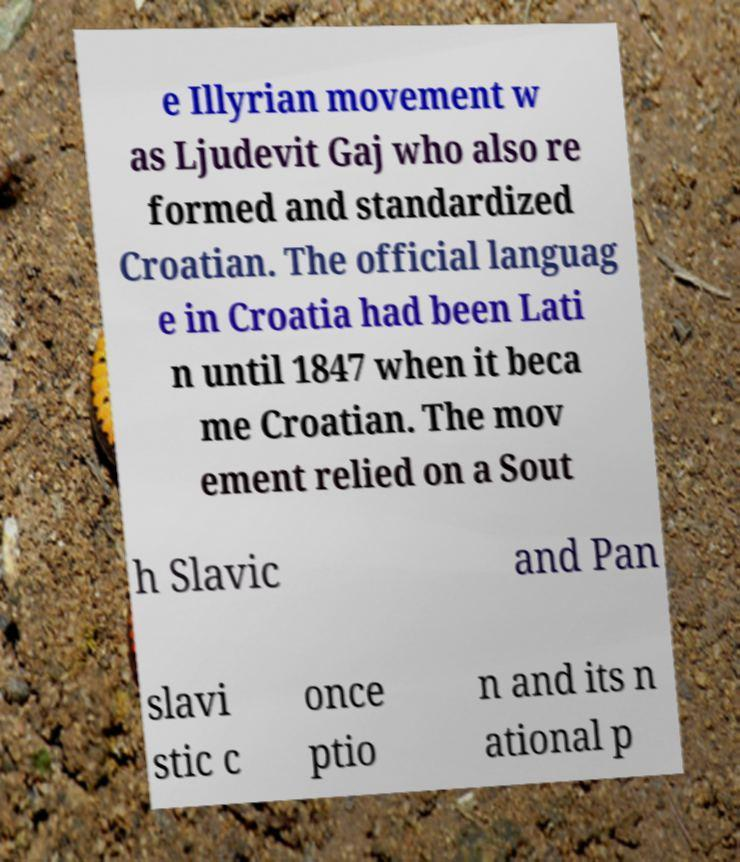Can you accurately transcribe the text from the provided image for me? e Illyrian movement w as Ljudevit Gaj who also re formed and standardized Croatian. The official languag e in Croatia had been Lati n until 1847 when it beca me Croatian. The mov ement relied on a Sout h Slavic and Pan slavi stic c once ptio n and its n ational p 